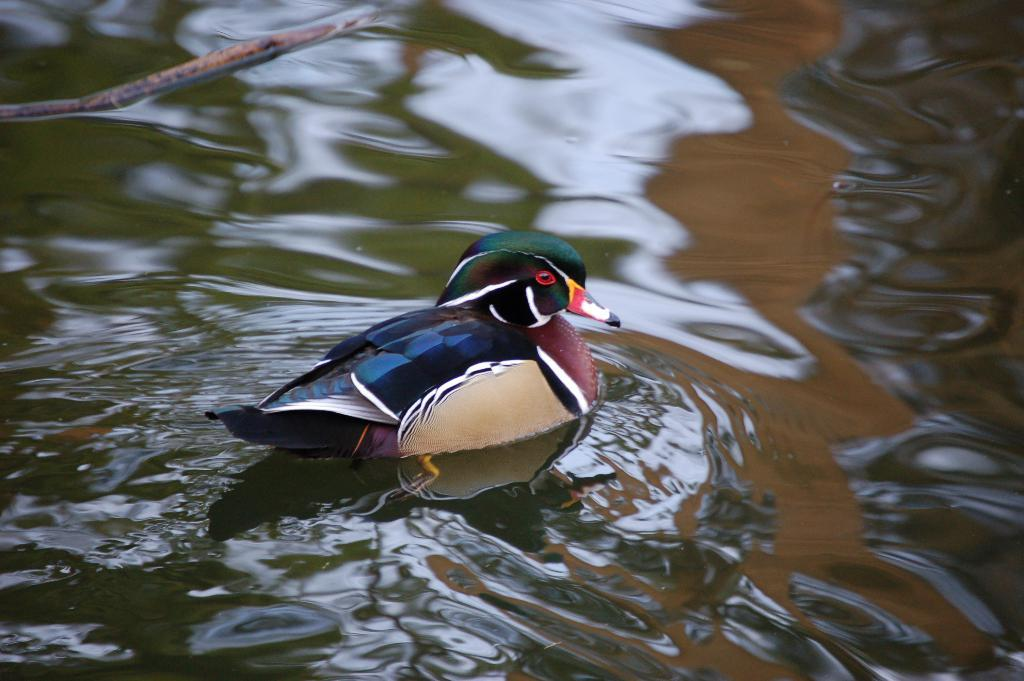What type of animal is in the picture? There is a wood duck in the picture. What is the wood duck doing in the picture? The wood duck is swimming in the water. What is a distinctive feature of the wood duck's appearance? The wood duck has a red color beak. What else can be seen in the water in the picture? There is a wooden stick in the water in the picture. What type of prison can be seen in the background of the image? There is no prison visible in the image; it features a wood duck swimming in the water with a wooden stick nearby. 